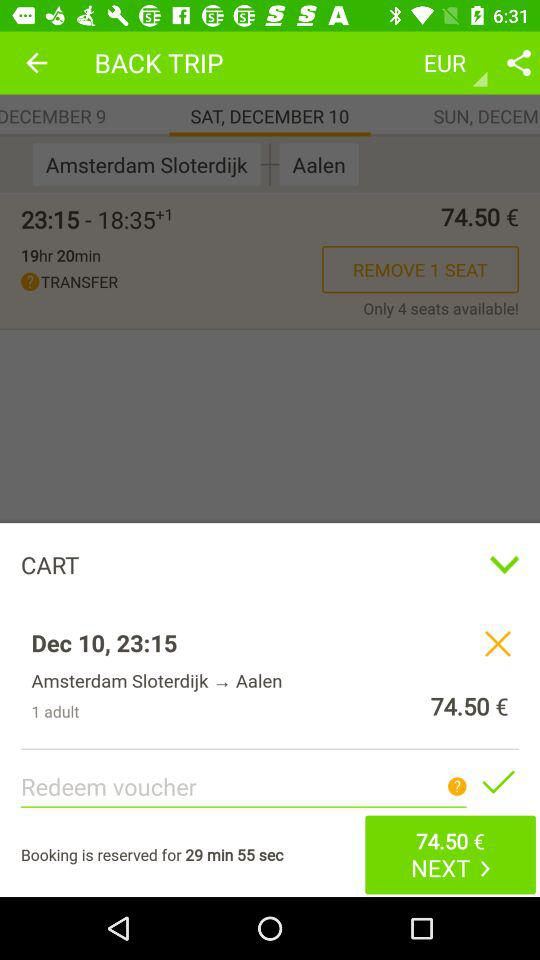How many adults are there? There is 1 adult. 